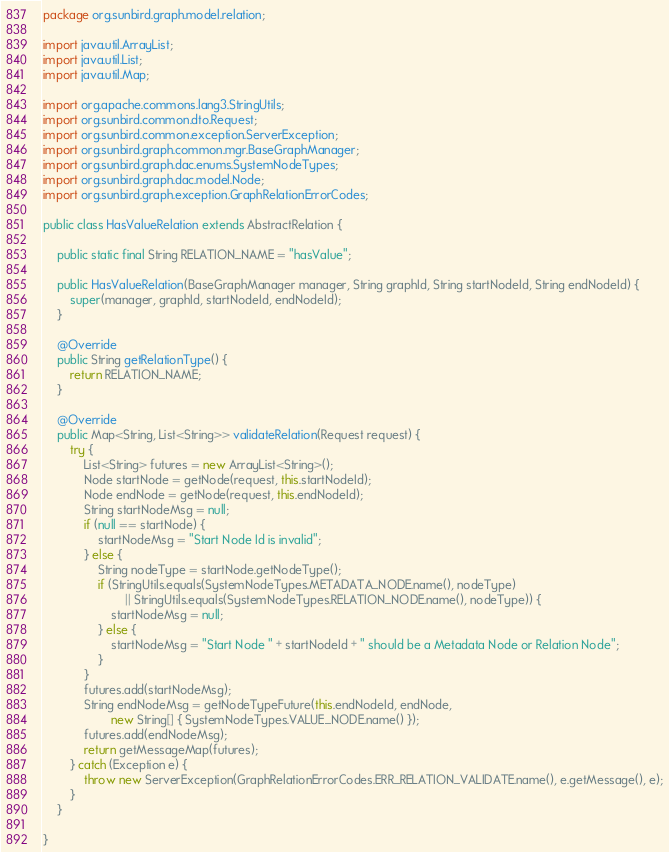Convert code to text. <code><loc_0><loc_0><loc_500><loc_500><_Java_>package org.sunbird.graph.model.relation;

import java.util.ArrayList;
import java.util.List;
import java.util.Map;

import org.apache.commons.lang3.StringUtils;
import org.sunbird.common.dto.Request;
import org.sunbird.common.exception.ServerException;
import org.sunbird.graph.common.mgr.BaseGraphManager;
import org.sunbird.graph.dac.enums.SystemNodeTypes;
import org.sunbird.graph.dac.model.Node;
import org.sunbird.graph.exception.GraphRelationErrorCodes;

public class HasValueRelation extends AbstractRelation {
    
    public static final String RELATION_NAME = "hasValue"; 

    public HasValueRelation(BaseGraphManager manager, String graphId, String startNodeId, String endNodeId) {
        super(manager, graphId, startNodeId, endNodeId);
    }

    @Override
    public String getRelationType() {
        return RELATION_NAME;
    }

    @Override
    public Map<String, List<String>> validateRelation(Request request) {
        try {
            List<String> futures = new ArrayList<String>();
            Node startNode = getNode(request, this.startNodeId);
            Node endNode = getNode(request, this.endNodeId);
            String startNodeMsg = null;
			if (null == startNode) {
				startNodeMsg = "Start Node Id is invalid";
			} else {
				String nodeType = startNode.getNodeType();
				if (StringUtils.equals(SystemNodeTypes.METADATA_NODE.name(), nodeType)
						|| StringUtils.equals(SystemNodeTypes.RELATION_NODE.name(), nodeType)) {
					startNodeMsg = null;
				} else {
					startNodeMsg = "Start Node " + startNodeId + " should be a Metadata Node or Relation Node";
                }
			}
            futures.add(startNodeMsg);
			String endNodeMsg = getNodeTypeFuture(this.endNodeId, endNode,
					new String[] { SystemNodeTypes.VALUE_NODE.name() });
            futures.add(endNodeMsg);
			return getMessageMap(futures);
        } catch (Exception e) {
            throw new ServerException(GraphRelationErrorCodes.ERR_RELATION_VALIDATE.name(), e.getMessage(), e);
        }
    }

}
</code> 